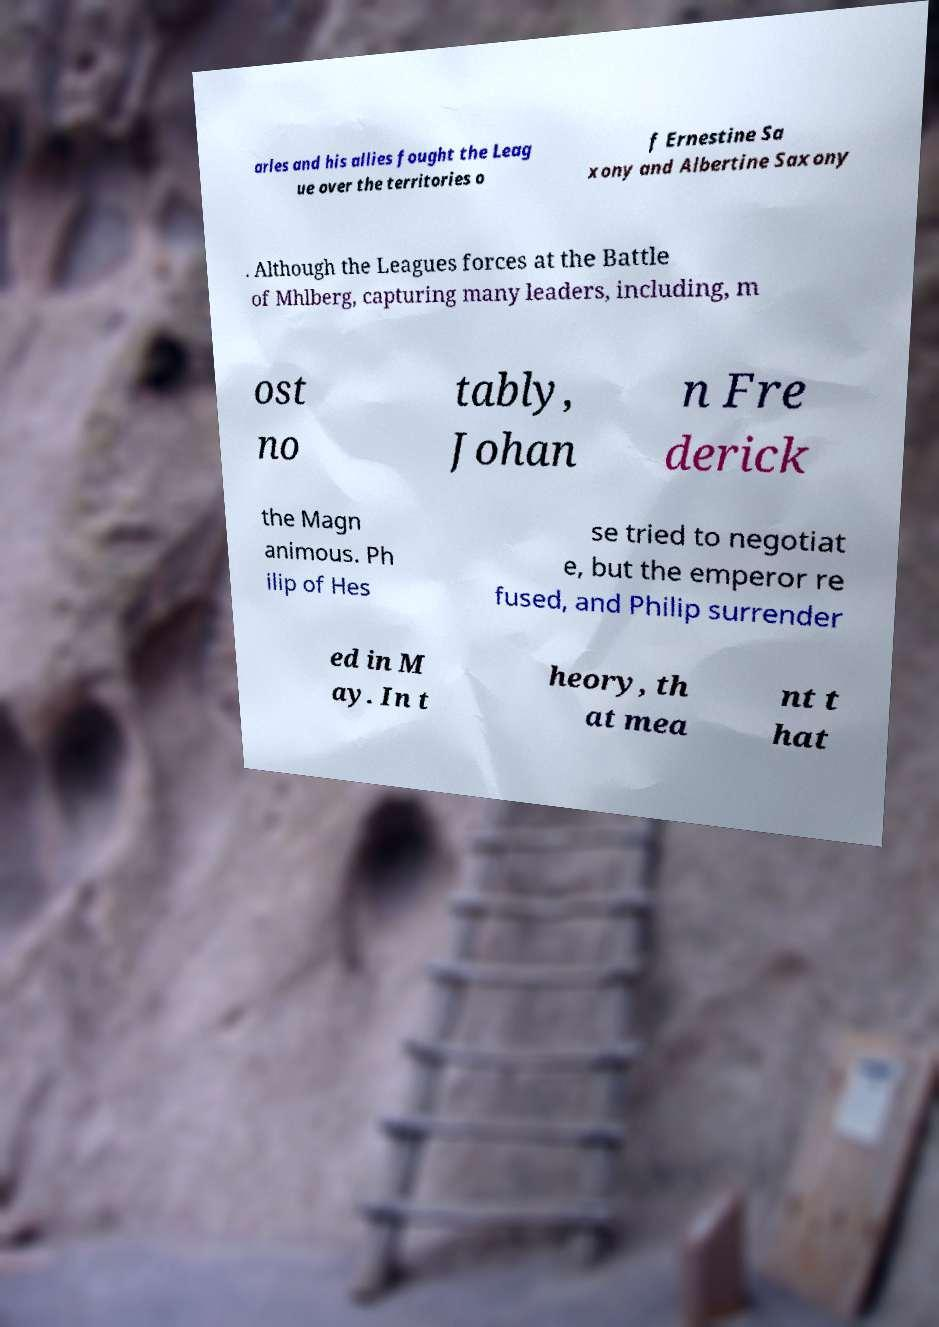There's text embedded in this image that I need extracted. Can you transcribe it verbatim? arles and his allies fought the Leag ue over the territories o f Ernestine Sa xony and Albertine Saxony . Although the Leagues forces at the Battle of Mhlberg, capturing many leaders, including, m ost no tably, Johan n Fre derick the Magn animous. Ph ilip of Hes se tried to negotiat e, but the emperor re fused, and Philip surrender ed in M ay. In t heory, th at mea nt t hat 